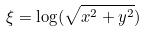<formula> <loc_0><loc_0><loc_500><loc_500>\xi = \log ( \sqrt { x ^ { 2 } + y ^ { 2 } } )</formula> 